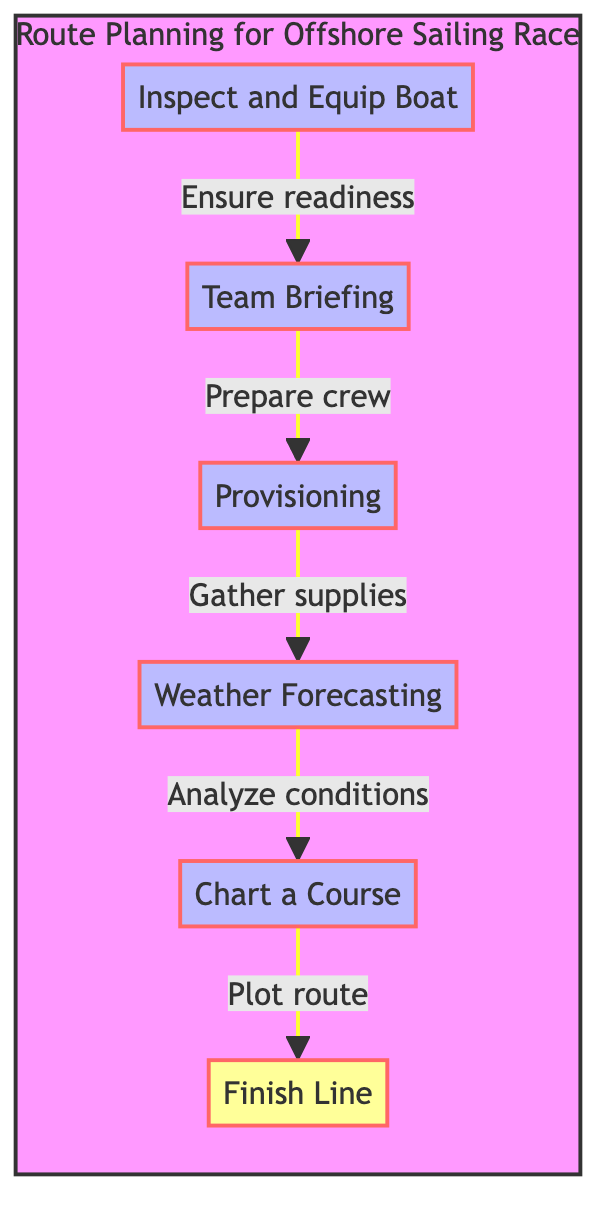What is the final step before reaching the Finish Line? The final step in the flow chart before reaching the Finish Line is "Chart a Course." This step is located just above "Finish Line" and shows the order of operations leading to the destination.
Answer: Chart a Course What is the initial step in the route planning process? The initial step in the process is "Inspect and Equip Boat." This is the bottom node in the flow chart, representing the first action to be taken before all other steps.
Answer: Inspect and Equip Boat How many steps are in the route planning flow chart? There are five steps in the route planning flow chart: "Inspect and Equip Boat," "Team Briefing," "Provisioning," "Weather Forecasting," and "Chart a Course." These are the labeled steps leading up to the Finish Line.
Answer: Five What step involves gathering supplies? The step that involves gathering supplies is "Provisioning." This is listed in the flow chart and connects "Team Briefing" and "Weather Forecasting."
Answer: Provisioning Which step directly follows the Weather Forecasting step? The step that directly follows "Weather Forecasting" is "Chart a Course." This connection shows the sequential order of actions taken during the route planning process.
Answer: Chart a Course What is the relationship between Team Briefing and Inspect and Equip Boat? "Team Briefing" follows "Inspect and Equip Boat," indicating that the crew preparation comes after ensuring the boat is ready. This relationship demonstrates the dependency of crew readiness on the boat's condition.
Answer: Team Briefing follows Inspect and Equip Boat 